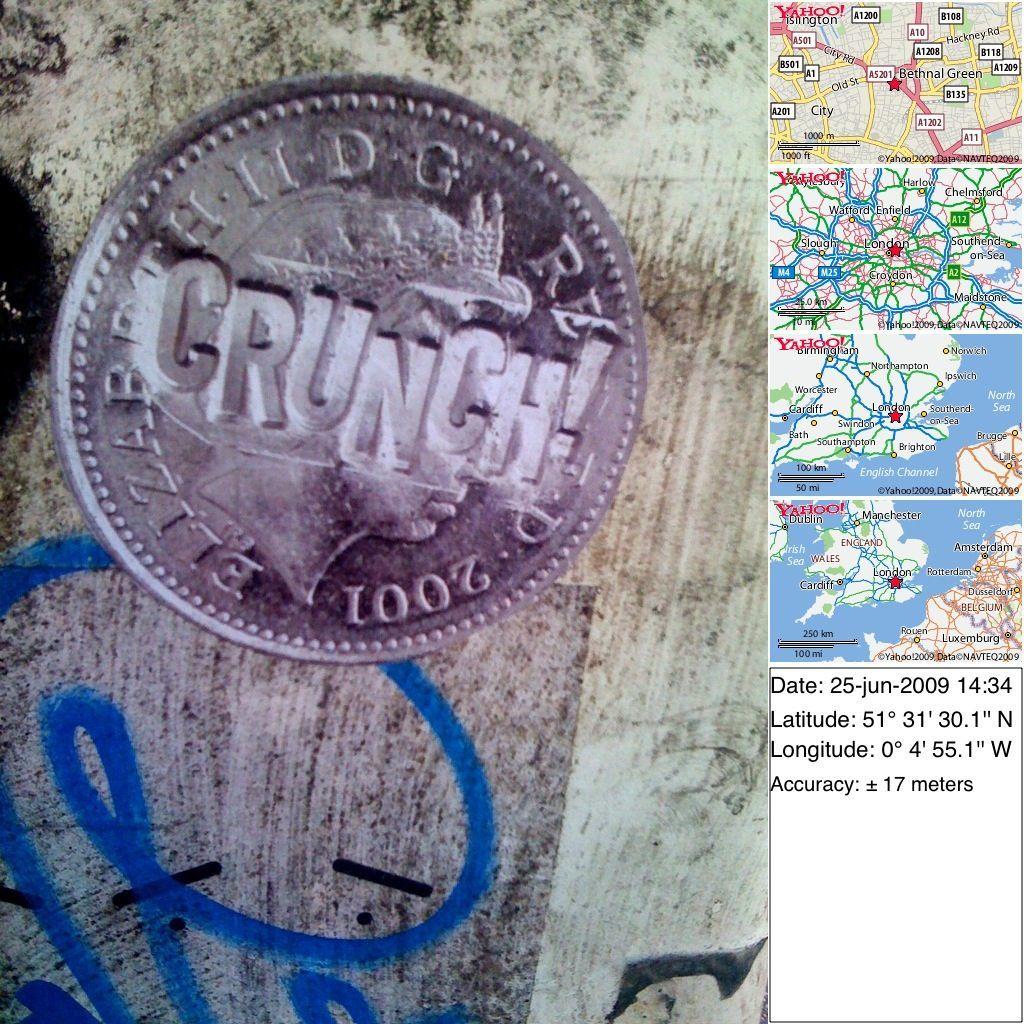What year is on the coin?
Provide a short and direct response. 2001. 